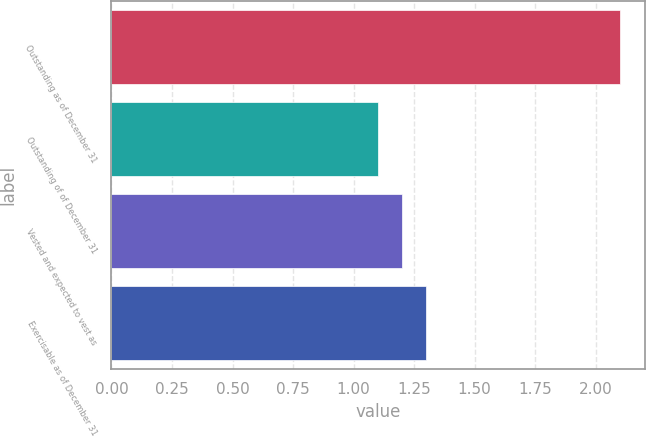Convert chart. <chart><loc_0><loc_0><loc_500><loc_500><bar_chart><fcel>Outstanding as of December 31<fcel>Outstanding of of December 31<fcel>Vested and expected to vest as<fcel>Exercisable as of December 31<nl><fcel>2.1<fcel>1.1<fcel>1.2<fcel>1.3<nl></chart> 